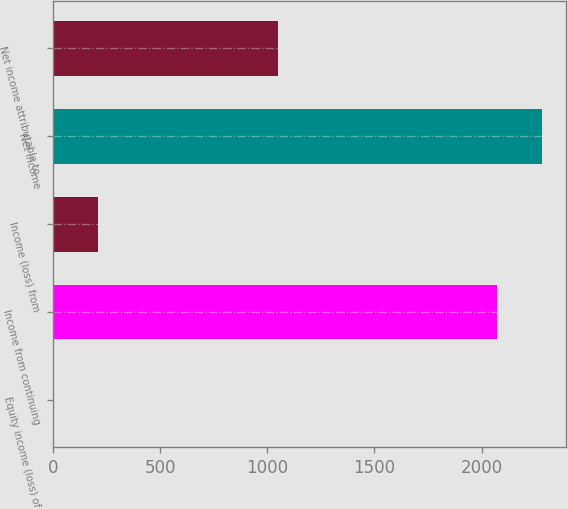Convert chart. <chart><loc_0><loc_0><loc_500><loc_500><bar_chart><fcel>Equity income (loss) of<fcel>Income from continuing<fcel>Income (loss) from<fcel>Net income<fcel>Net income attributable to<nl><fcel>2<fcel>2072<fcel>209.2<fcel>2279.2<fcel>1048<nl></chart> 